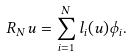<formula> <loc_0><loc_0><loc_500><loc_500>R _ { N } u = \sum _ { i = 1 } ^ { N } l _ { i } ( u ) \phi _ { i } .</formula> 